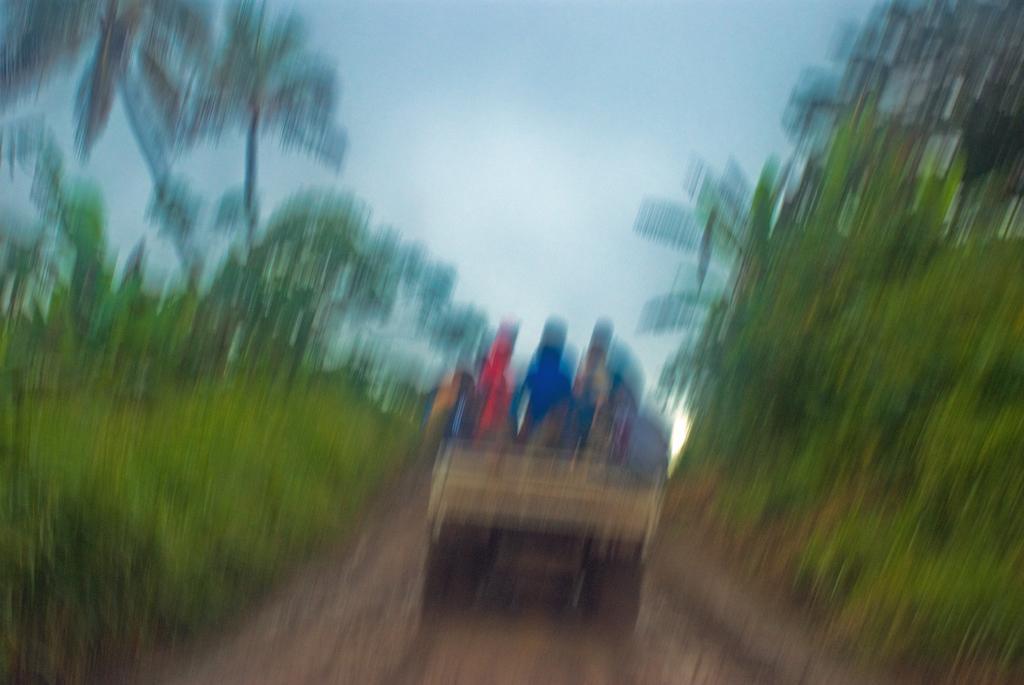How would you summarize this image in a sentence or two? This image is blur where we can see a vehicle on which there are few people. On either sides, there is greenery. At the top, there is the sky. 